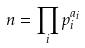Convert formula to latex. <formula><loc_0><loc_0><loc_500><loc_500>n = \prod _ { i } p _ { i } ^ { a _ { i } }</formula> 